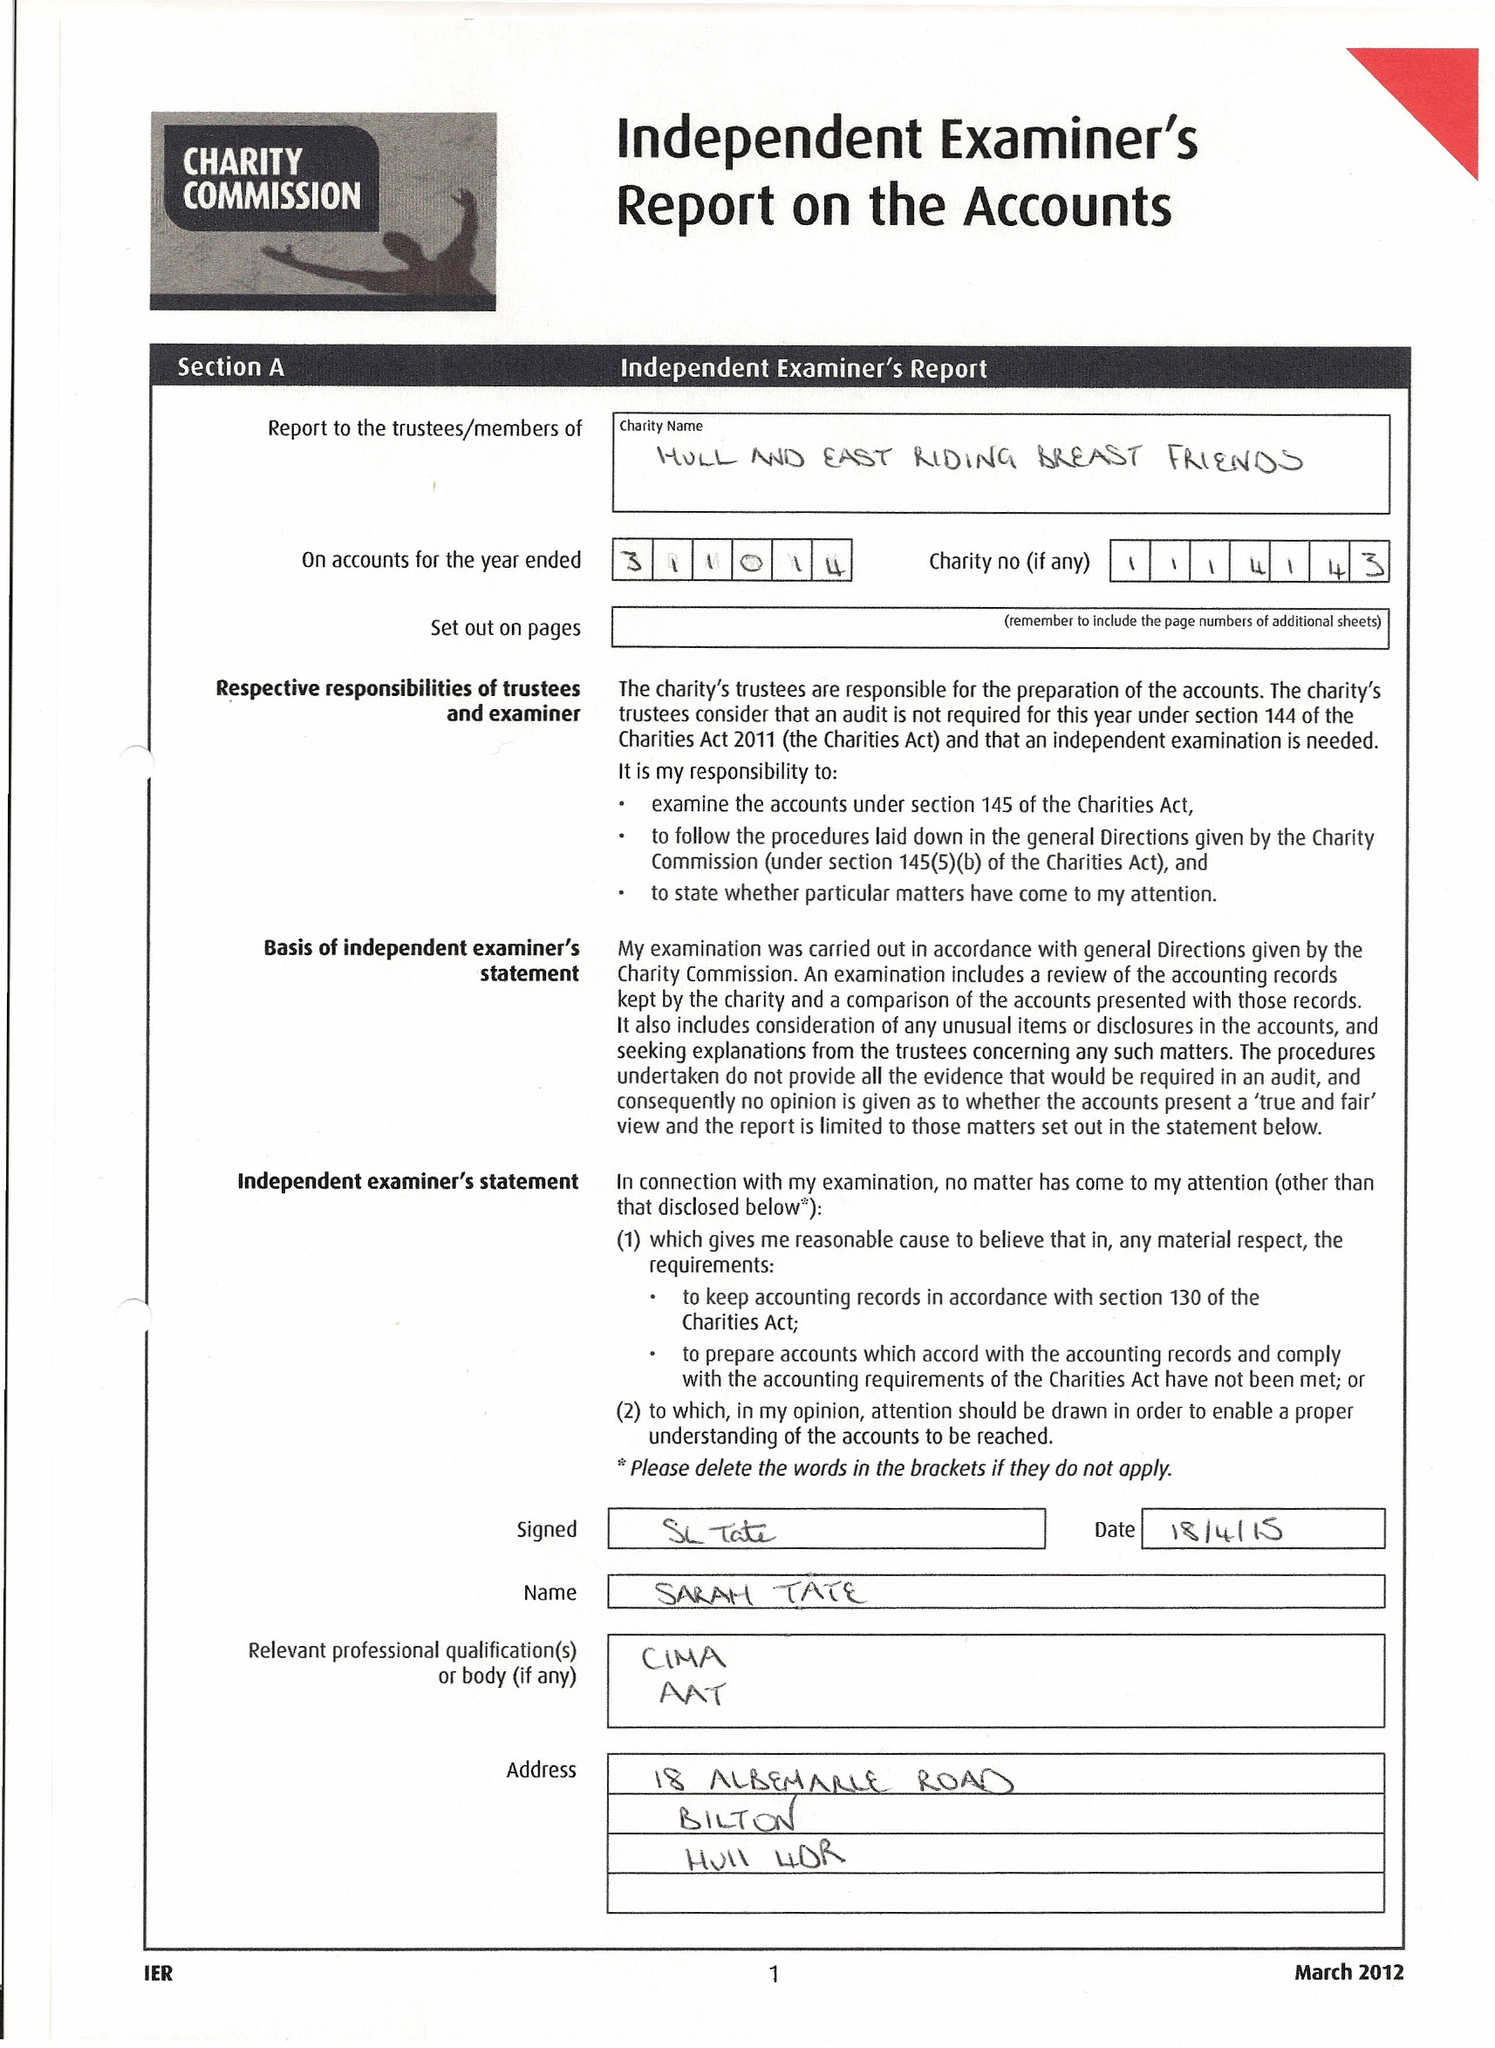What is the value for the charity_number?
Answer the question using a single word or phrase. 1114143 